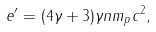<formula> <loc_0><loc_0><loc_500><loc_500>e ^ { \prime } = ( 4 \gamma + 3 ) \gamma n m _ { p } c ^ { 2 } ,</formula> 